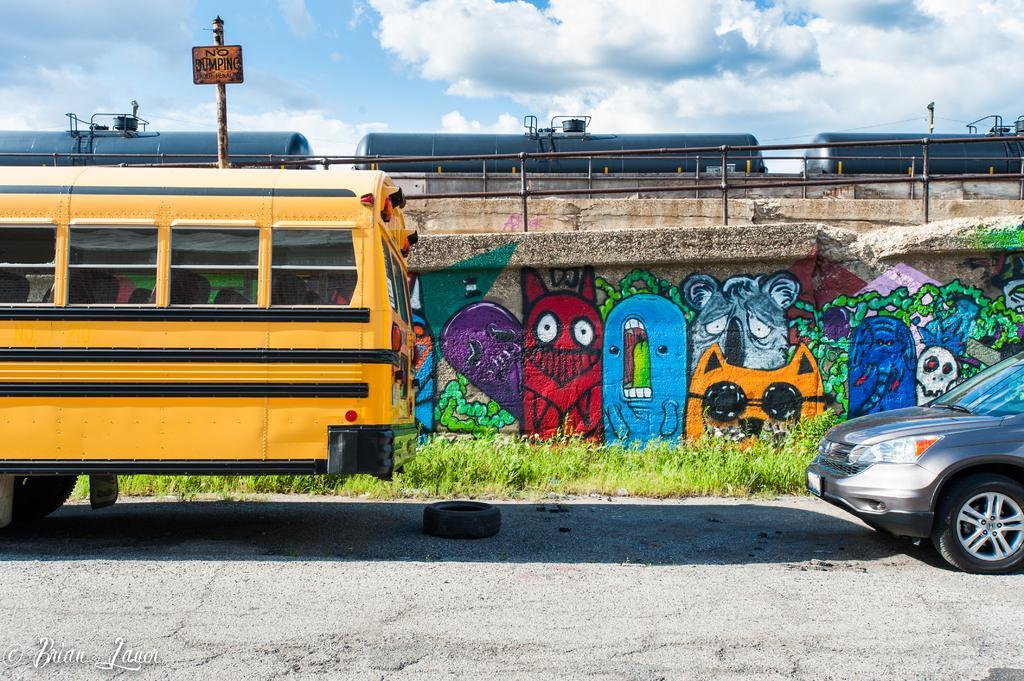Could you give a brief overview of what you see in this image? In this image I can see a bus which is yellow and black in color on the road and another car which aid grey in color on the road. I can see a black colored Tyre in between the vehicles. In the background I can see some grass, the wall, some painting on the wall, a train, a pole and the sky. 